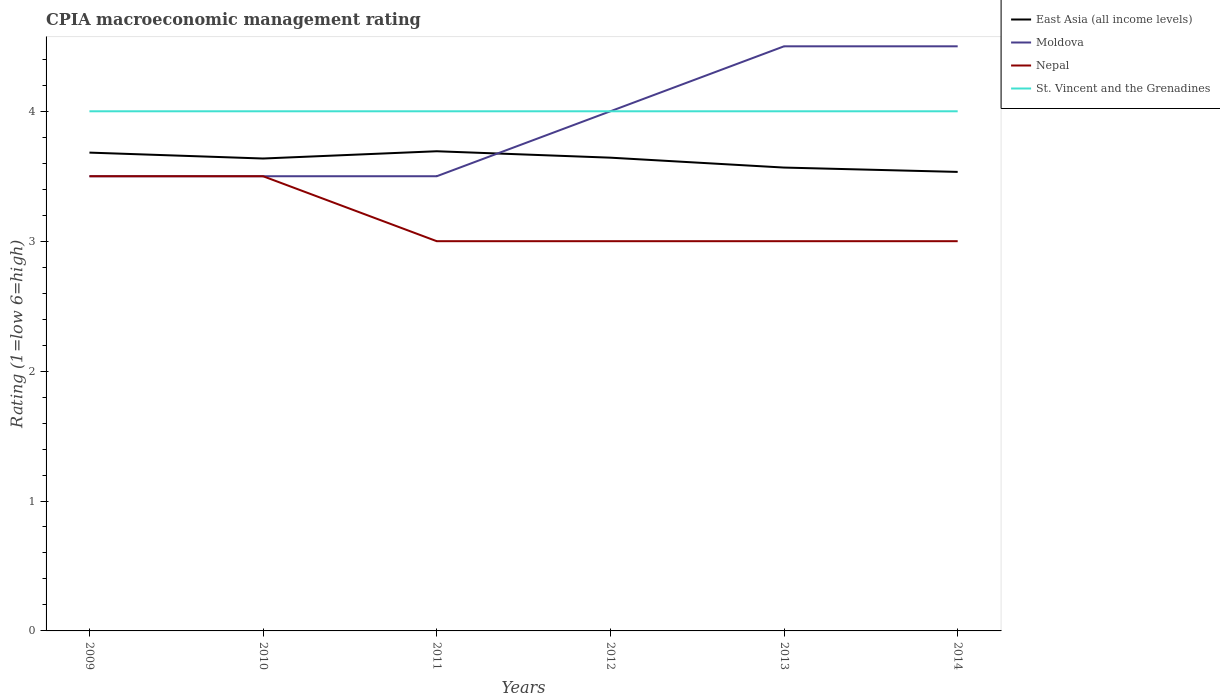Does the line corresponding to East Asia (all income levels) intersect with the line corresponding to Nepal?
Provide a succinct answer. No. In which year was the CPIA rating in Nepal maximum?
Provide a short and direct response. 2011. What is the total CPIA rating in St. Vincent and the Grenadines in the graph?
Your answer should be compact. 0. What is the difference between the highest and the second highest CPIA rating in Nepal?
Keep it short and to the point. 0.5. What is the difference between the highest and the lowest CPIA rating in St. Vincent and the Grenadines?
Provide a succinct answer. 0. Is the CPIA rating in East Asia (all income levels) strictly greater than the CPIA rating in Moldova over the years?
Give a very brief answer. No. How many lines are there?
Offer a very short reply. 4. How many years are there in the graph?
Provide a short and direct response. 6. What is the difference between two consecutive major ticks on the Y-axis?
Ensure brevity in your answer.  1. Does the graph contain any zero values?
Give a very brief answer. No. Does the graph contain grids?
Offer a very short reply. No. How are the legend labels stacked?
Provide a succinct answer. Vertical. What is the title of the graph?
Offer a terse response. CPIA macroeconomic management rating. What is the label or title of the Y-axis?
Your answer should be very brief. Rating (1=low 6=high). What is the Rating (1=low 6=high) in East Asia (all income levels) in 2009?
Your answer should be compact. 3.68. What is the Rating (1=low 6=high) in Nepal in 2009?
Give a very brief answer. 3.5. What is the Rating (1=low 6=high) in East Asia (all income levels) in 2010?
Keep it short and to the point. 3.64. What is the Rating (1=low 6=high) in Nepal in 2010?
Your response must be concise. 3.5. What is the Rating (1=low 6=high) in St. Vincent and the Grenadines in 2010?
Your response must be concise. 4. What is the Rating (1=low 6=high) in East Asia (all income levels) in 2011?
Make the answer very short. 3.69. What is the Rating (1=low 6=high) in St. Vincent and the Grenadines in 2011?
Offer a terse response. 4. What is the Rating (1=low 6=high) in East Asia (all income levels) in 2012?
Your response must be concise. 3.64. What is the Rating (1=low 6=high) of Moldova in 2012?
Make the answer very short. 4. What is the Rating (1=low 6=high) of East Asia (all income levels) in 2013?
Your response must be concise. 3.57. What is the Rating (1=low 6=high) in Nepal in 2013?
Provide a short and direct response. 3. What is the Rating (1=low 6=high) of St. Vincent and the Grenadines in 2013?
Ensure brevity in your answer.  4. What is the Rating (1=low 6=high) in East Asia (all income levels) in 2014?
Offer a very short reply. 3.53. What is the Rating (1=low 6=high) of Moldova in 2014?
Give a very brief answer. 4.5. What is the Rating (1=low 6=high) of Nepal in 2014?
Make the answer very short. 3. Across all years, what is the maximum Rating (1=low 6=high) of East Asia (all income levels)?
Provide a short and direct response. 3.69. Across all years, what is the maximum Rating (1=low 6=high) in Nepal?
Make the answer very short. 3.5. Across all years, what is the minimum Rating (1=low 6=high) of East Asia (all income levels)?
Your response must be concise. 3.53. Across all years, what is the minimum Rating (1=low 6=high) in St. Vincent and the Grenadines?
Offer a very short reply. 4. What is the total Rating (1=low 6=high) of East Asia (all income levels) in the graph?
Make the answer very short. 21.75. What is the total Rating (1=low 6=high) in Nepal in the graph?
Your response must be concise. 19. What is the total Rating (1=low 6=high) of St. Vincent and the Grenadines in the graph?
Provide a short and direct response. 24. What is the difference between the Rating (1=low 6=high) of East Asia (all income levels) in 2009 and that in 2010?
Ensure brevity in your answer.  0.05. What is the difference between the Rating (1=low 6=high) of Nepal in 2009 and that in 2010?
Your response must be concise. 0. What is the difference between the Rating (1=low 6=high) of St. Vincent and the Grenadines in 2009 and that in 2010?
Offer a very short reply. 0. What is the difference between the Rating (1=low 6=high) in East Asia (all income levels) in 2009 and that in 2011?
Your response must be concise. -0.01. What is the difference between the Rating (1=low 6=high) of East Asia (all income levels) in 2009 and that in 2012?
Your answer should be compact. 0.04. What is the difference between the Rating (1=low 6=high) of Moldova in 2009 and that in 2012?
Provide a short and direct response. -0.5. What is the difference between the Rating (1=low 6=high) in Nepal in 2009 and that in 2012?
Ensure brevity in your answer.  0.5. What is the difference between the Rating (1=low 6=high) in St. Vincent and the Grenadines in 2009 and that in 2012?
Ensure brevity in your answer.  0. What is the difference between the Rating (1=low 6=high) in East Asia (all income levels) in 2009 and that in 2013?
Your answer should be compact. 0.12. What is the difference between the Rating (1=low 6=high) of East Asia (all income levels) in 2009 and that in 2014?
Offer a very short reply. 0.15. What is the difference between the Rating (1=low 6=high) of Nepal in 2009 and that in 2014?
Your answer should be very brief. 0.5. What is the difference between the Rating (1=low 6=high) in East Asia (all income levels) in 2010 and that in 2011?
Your answer should be very brief. -0.06. What is the difference between the Rating (1=low 6=high) in Nepal in 2010 and that in 2011?
Your answer should be compact. 0.5. What is the difference between the Rating (1=low 6=high) in St. Vincent and the Grenadines in 2010 and that in 2011?
Give a very brief answer. 0. What is the difference between the Rating (1=low 6=high) in East Asia (all income levels) in 2010 and that in 2012?
Your answer should be compact. -0.01. What is the difference between the Rating (1=low 6=high) in Nepal in 2010 and that in 2012?
Your response must be concise. 0.5. What is the difference between the Rating (1=low 6=high) in East Asia (all income levels) in 2010 and that in 2013?
Ensure brevity in your answer.  0.07. What is the difference between the Rating (1=low 6=high) in Nepal in 2010 and that in 2013?
Provide a short and direct response. 0.5. What is the difference between the Rating (1=low 6=high) of East Asia (all income levels) in 2010 and that in 2014?
Your answer should be very brief. 0.1. What is the difference between the Rating (1=low 6=high) of Moldova in 2010 and that in 2014?
Keep it short and to the point. -1. What is the difference between the Rating (1=low 6=high) in St. Vincent and the Grenadines in 2010 and that in 2014?
Provide a succinct answer. 0. What is the difference between the Rating (1=low 6=high) in East Asia (all income levels) in 2011 and that in 2012?
Provide a short and direct response. 0.05. What is the difference between the Rating (1=low 6=high) in Moldova in 2011 and that in 2012?
Your answer should be compact. -0.5. What is the difference between the Rating (1=low 6=high) in Nepal in 2011 and that in 2012?
Provide a succinct answer. 0. What is the difference between the Rating (1=low 6=high) of St. Vincent and the Grenadines in 2011 and that in 2012?
Provide a succinct answer. 0. What is the difference between the Rating (1=low 6=high) in East Asia (all income levels) in 2011 and that in 2013?
Your answer should be compact. 0.13. What is the difference between the Rating (1=low 6=high) of Moldova in 2011 and that in 2013?
Your answer should be compact. -1. What is the difference between the Rating (1=low 6=high) in Nepal in 2011 and that in 2013?
Provide a short and direct response. 0. What is the difference between the Rating (1=low 6=high) in St. Vincent and the Grenadines in 2011 and that in 2013?
Your response must be concise. 0. What is the difference between the Rating (1=low 6=high) of East Asia (all income levels) in 2011 and that in 2014?
Provide a short and direct response. 0.16. What is the difference between the Rating (1=low 6=high) of Moldova in 2011 and that in 2014?
Your response must be concise. -1. What is the difference between the Rating (1=low 6=high) of St. Vincent and the Grenadines in 2011 and that in 2014?
Your answer should be very brief. 0. What is the difference between the Rating (1=low 6=high) of East Asia (all income levels) in 2012 and that in 2013?
Offer a terse response. 0.08. What is the difference between the Rating (1=low 6=high) in Moldova in 2012 and that in 2013?
Ensure brevity in your answer.  -0.5. What is the difference between the Rating (1=low 6=high) of East Asia (all income levels) in 2012 and that in 2014?
Your response must be concise. 0.11. What is the difference between the Rating (1=low 6=high) in Nepal in 2012 and that in 2014?
Give a very brief answer. 0. What is the difference between the Rating (1=low 6=high) of St. Vincent and the Grenadines in 2012 and that in 2014?
Keep it short and to the point. 0. What is the difference between the Rating (1=low 6=high) in Moldova in 2013 and that in 2014?
Keep it short and to the point. 0. What is the difference between the Rating (1=low 6=high) of East Asia (all income levels) in 2009 and the Rating (1=low 6=high) of Moldova in 2010?
Offer a very short reply. 0.18. What is the difference between the Rating (1=low 6=high) in East Asia (all income levels) in 2009 and the Rating (1=low 6=high) in Nepal in 2010?
Give a very brief answer. 0.18. What is the difference between the Rating (1=low 6=high) in East Asia (all income levels) in 2009 and the Rating (1=low 6=high) in St. Vincent and the Grenadines in 2010?
Offer a terse response. -0.32. What is the difference between the Rating (1=low 6=high) of Nepal in 2009 and the Rating (1=low 6=high) of St. Vincent and the Grenadines in 2010?
Keep it short and to the point. -0.5. What is the difference between the Rating (1=low 6=high) of East Asia (all income levels) in 2009 and the Rating (1=low 6=high) of Moldova in 2011?
Your response must be concise. 0.18. What is the difference between the Rating (1=low 6=high) in East Asia (all income levels) in 2009 and the Rating (1=low 6=high) in Nepal in 2011?
Your answer should be compact. 0.68. What is the difference between the Rating (1=low 6=high) in East Asia (all income levels) in 2009 and the Rating (1=low 6=high) in St. Vincent and the Grenadines in 2011?
Your response must be concise. -0.32. What is the difference between the Rating (1=low 6=high) of Moldova in 2009 and the Rating (1=low 6=high) of Nepal in 2011?
Your response must be concise. 0.5. What is the difference between the Rating (1=low 6=high) of East Asia (all income levels) in 2009 and the Rating (1=low 6=high) of Moldova in 2012?
Keep it short and to the point. -0.32. What is the difference between the Rating (1=low 6=high) of East Asia (all income levels) in 2009 and the Rating (1=low 6=high) of Nepal in 2012?
Make the answer very short. 0.68. What is the difference between the Rating (1=low 6=high) of East Asia (all income levels) in 2009 and the Rating (1=low 6=high) of St. Vincent and the Grenadines in 2012?
Your response must be concise. -0.32. What is the difference between the Rating (1=low 6=high) in East Asia (all income levels) in 2009 and the Rating (1=low 6=high) in Moldova in 2013?
Provide a succinct answer. -0.82. What is the difference between the Rating (1=low 6=high) of East Asia (all income levels) in 2009 and the Rating (1=low 6=high) of Nepal in 2013?
Offer a very short reply. 0.68. What is the difference between the Rating (1=low 6=high) of East Asia (all income levels) in 2009 and the Rating (1=low 6=high) of St. Vincent and the Grenadines in 2013?
Provide a succinct answer. -0.32. What is the difference between the Rating (1=low 6=high) in Moldova in 2009 and the Rating (1=low 6=high) in Nepal in 2013?
Offer a very short reply. 0.5. What is the difference between the Rating (1=low 6=high) in Moldova in 2009 and the Rating (1=low 6=high) in St. Vincent and the Grenadines in 2013?
Ensure brevity in your answer.  -0.5. What is the difference between the Rating (1=low 6=high) of East Asia (all income levels) in 2009 and the Rating (1=low 6=high) of Moldova in 2014?
Make the answer very short. -0.82. What is the difference between the Rating (1=low 6=high) in East Asia (all income levels) in 2009 and the Rating (1=low 6=high) in Nepal in 2014?
Keep it short and to the point. 0.68. What is the difference between the Rating (1=low 6=high) in East Asia (all income levels) in 2009 and the Rating (1=low 6=high) in St. Vincent and the Grenadines in 2014?
Offer a terse response. -0.32. What is the difference between the Rating (1=low 6=high) in Moldova in 2009 and the Rating (1=low 6=high) in Nepal in 2014?
Ensure brevity in your answer.  0.5. What is the difference between the Rating (1=low 6=high) in East Asia (all income levels) in 2010 and the Rating (1=low 6=high) in Moldova in 2011?
Give a very brief answer. 0.14. What is the difference between the Rating (1=low 6=high) in East Asia (all income levels) in 2010 and the Rating (1=low 6=high) in Nepal in 2011?
Make the answer very short. 0.64. What is the difference between the Rating (1=low 6=high) in East Asia (all income levels) in 2010 and the Rating (1=low 6=high) in St. Vincent and the Grenadines in 2011?
Your answer should be compact. -0.36. What is the difference between the Rating (1=low 6=high) of East Asia (all income levels) in 2010 and the Rating (1=low 6=high) of Moldova in 2012?
Your answer should be very brief. -0.36. What is the difference between the Rating (1=low 6=high) in East Asia (all income levels) in 2010 and the Rating (1=low 6=high) in Nepal in 2012?
Ensure brevity in your answer.  0.64. What is the difference between the Rating (1=low 6=high) of East Asia (all income levels) in 2010 and the Rating (1=low 6=high) of St. Vincent and the Grenadines in 2012?
Make the answer very short. -0.36. What is the difference between the Rating (1=low 6=high) of Moldova in 2010 and the Rating (1=low 6=high) of Nepal in 2012?
Give a very brief answer. 0.5. What is the difference between the Rating (1=low 6=high) in East Asia (all income levels) in 2010 and the Rating (1=low 6=high) in Moldova in 2013?
Ensure brevity in your answer.  -0.86. What is the difference between the Rating (1=low 6=high) in East Asia (all income levels) in 2010 and the Rating (1=low 6=high) in Nepal in 2013?
Make the answer very short. 0.64. What is the difference between the Rating (1=low 6=high) in East Asia (all income levels) in 2010 and the Rating (1=low 6=high) in St. Vincent and the Grenadines in 2013?
Provide a short and direct response. -0.36. What is the difference between the Rating (1=low 6=high) of Moldova in 2010 and the Rating (1=low 6=high) of St. Vincent and the Grenadines in 2013?
Offer a terse response. -0.5. What is the difference between the Rating (1=low 6=high) in Nepal in 2010 and the Rating (1=low 6=high) in St. Vincent and the Grenadines in 2013?
Offer a very short reply. -0.5. What is the difference between the Rating (1=low 6=high) of East Asia (all income levels) in 2010 and the Rating (1=low 6=high) of Moldova in 2014?
Offer a terse response. -0.86. What is the difference between the Rating (1=low 6=high) of East Asia (all income levels) in 2010 and the Rating (1=low 6=high) of Nepal in 2014?
Give a very brief answer. 0.64. What is the difference between the Rating (1=low 6=high) in East Asia (all income levels) in 2010 and the Rating (1=low 6=high) in St. Vincent and the Grenadines in 2014?
Your answer should be compact. -0.36. What is the difference between the Rating (1=low 6=high) of Nepal in 2010 and the Rating (1=low 6=high) of St. Vincent and the Grenadines in 2014?
Give a very brief answer. -0.5. What is the difference between the Rating (1=low 6=high) of East Asia (all income levels) in 2011 and the Rating (1=low 6=high) of Moldova in 2012?
Keep it short and to the point. -0.31. What is the difference between the Rating (1=low 6=high) of East Asia (all income levels) in 2011 and the Rating (1=low 6=high) of Nepal in 2012?
Ensure brevity in your answer.  0.69. What is the difference between the Rating (1=low 6=high) of East Asia (all income levels) in 2011 and the Rating (1=low 6=high) of St. Vincent and the Grenadines in 2012?
Offer a very short reply. -0.31. What is the difference between the Rating (1=low 6=high) in East Asia (all income levels) in 2011 and the Rating (1=low 6=high) in Moldova in 2013?
Provide a short and direct response. -0.81. What is the difference between the Rating (1=low 6=high) in East Asia (all income levels) in 2011 and the Rating (1=low 6=high) in Nepal in 2013?
Give a very brief answer. 0.69. What is the difference between the Rating (1=low 6=high) in East Asia (all income levels) in 2011 and the Rating (1=low 6=high) in St. Vincent and the Grenadines in 2013?
Ensure brevity in your answer.  -0.31. What is the difference between the Rating (1=low 6=high) in Moldova in 2011 and the Rating (1=low 6=high) in Nepal in 2013?
Make the answer very short. 0.5. What is the difference between the Rating (1=low 6=high) of East Asia (all income levels) in 2011 and the Rating (1=low 6=high) of Moldova in 2014?
Your answer should be compact. -0.81. What is the difference between the Rating (1=low 6=high) of East Asia (all income levels) in 2011 and the Rating (1=low 6=high) of Nepal in 2014?
Make the answer very short. 0.69. What is the difference between the Rating (1=low 6=high) of East Asia (all income levels) in 2011 and the Rating (1=low 6=high) of St. Vincent and the Grenadines in 2014?
Keep it short and to the point. -0.31. What is the difference between the Rating (1=low 6=high) of Moldova in 2011 and the Rating (1=low 6=high) of St. Vincent and the Grenadines in 2014?
Give a very brief answer. -0.5. What is the difference between the Rating (1=low 6=high) in Nepal in 2011 and the Rating (1=low 6=high) in St. Vincent and the Grenadines in 2014?
Offer a very short reply. -1. What is the difference between the Rating (1=low 6=high) of East Asia (all income levels) in 2012 and the Rating (1=low 6=high) of Moldova in 2013?
Your answer should be very brief. -0.86. What is the difference between the Rating (1=low 6=high) in East Asia (all income levels) in 2012 and the Rating (1=low 6=high) in Nepal in 2013?
Offer a terse response. 0.64. What is the difference between the Rating (1=low 6=high) of East Asia (all income levels) in 2012 and the Rating (1=low 6=high) of St. Vincent and the Grenadines in 2013?
Your response must be concise. -0.36. What is the difference between the Rating (1=low 6=high) in Moldova in 2012 and the Rating (1=low 6=high) in Nepal in 2013?
Your answer should be compact. 1. What is the difference between the Rating (1=low 6=high) of Moldova in 2012 and the Rating (1=low 6=high) of St. Vincent and the Grenadines in 2013?
Your answer should be compact. 0. What is the difference between the Rating (1=low 6=high) in East Asia (all income levels) in 2012 and the Rating (1=low 6=high) in Moldova in 2014?
Give a very brief answer. -0.86. What is the difference between the Rating (1=low 6=high) of East Asia (all income levels) in 2012 and the Rating (1=low 6=high) of Nepal in 2014?
Provide a succinct answer. 0.64. What is the difference between the Rating (1=low 6=high) in East Asia (all income levels) in 2012 and the Rating (1=low 6=high) in St. Vincent and the Grenadines in 2014?
Make the answer very short. -0.36. What is the difference between the Rating (1=low 6=high) in Moldova in 2012 and the Rating (1=low 6=high) in Nepal in 2014?
Keep it short and to the point. 1. What is the difference between the Rating (1=low 6=high) in Moldova in 2012 and the Rating (1=low 6=high) in St. Vincent and the Grenadines in 2014?
Your answer should be very brief. 0. What is the difference between the Rating (1=low 6=high) in East Asia (all income levels) in 2013 and the Rating (1=low 6=high) in Moldova in 2014?
Provide a succinct answer. -0.93. What is the difference between the Rating (1=low 6=high) in East Asia (all income levels) in 2013 and the Rating (1=low 6=high) in Nepal in 2014?
Offer a terse response. 0.57. What is the difference between the Rating (1=low 6=high) of East Asia (all income levels) in 2013 and the Rating (1=low 6=high) of St. Vincent and the Grenadines in 2014?
Offer a terse response. -0.43. What is the difference between the Rating (1=low 6=high) of Nepal in 2013 and the Rating (1=low 6=high) of St. Vincent and the Grenadines in 2014?
Provide a short and direct response. -1. What is the average Rating (1=low 6=high) of East Asia (all income levels) per year?
Provide a succinct answer. 3.63. What is the average Rating (1=low 6=high) in Moldova per year?
Make the answer very short. 3.92. What is the average Rating (1=low 6=high) in Nepal per year?
Keep it short and to the point. 3.17. What is the average Rating (1=low 6=high) of St. Vincent and the Grenadines per year?
Provide a short and direct response. 4. In the year 2009, what is the difference between the Rating (1=low 6=high) of East Asia (all income levels) and Rating (1=low 6=high) of Moldova?
Your answer should be compact. 0.18. In the year 2009, what is the difference between the Rating (1=low 6=high) in East Asia (all income levels) and Rating (1=low 6=high) in Nepal?
Offer a very short reply. 0.18. In the year 2009, what is the difference between the Rating (1=low 6=high) in East Asia (all income levels) and Rating (1=low 6=high) in St. Vincent and the Grenadines?
Provide a short and direct response. -0.32. In the year 2009, what is the difference between the Rating (1=low 6=high) of Moldova and Rating (1=low 6=high) of St. Vincent and the Grenadines?
Your answer should be very brief. -0.5. In the year 2009, what is the difference between the Rating (1=low 6=high) of Nepal and Rating (1=low 6=high) of St. Vincent and the Grenadines?
Your response must be concise. -0.5. In the year 2010, what is the difference between the Rating (1=low 6=high) in East Asia (all income levels) and Rating (1=low 6=high) in Moldova?
Ensure brevity in your answer.  0.14. In the year 2010, what is the difference between the Rating (1=low 6=high) in East Asia (all income levels) and Rating (1=low 6=high) in Nepal?
Your response must be concise. 0.14. In the year 2010, what is the difference between the Rating (1=low 6=high) of East Asia (all income levels) and Rating (1=low 6=high) of St. Vincent and the Grenadines?
Offer a terse response. -0.36. In the year 2010, what is the difference between the Rating (1=low 6=high) in Moldova and Rating (1=low 6=high) in St. Vincent and the Grenadines?
Offer a very short reply. -0.5. In the year 2010, what is the difference between the Rating (1=low 6=high) of Nepal and Rating (1=low 6=high) of St. Vincent and the Grenadines?
Offer a terse response. -0.5. In the year 2011, what is the difference between the Rating (1=low 6=high) in East Asia (all income levels) and Rating (1=low 6=high) in Moldova?
Ensure brevity in your answer.  0.19. In the year 2011, what is the difference between the Rating (1=low 6=high) in East Asia (all income levels) and Rating (1=low 6=high) in Nepal?
Your answer should be compact. 0.69. In the year 2011, what is the difference between the Rating (1=low 6=high) of East Asia (all income levels) and Rating (1=low 6=high) of St. Vincent and the Grenadines?
Ensure brevity in your answer.  -0.31. In the year 2011, what is the difference between the Rating (1=low 6=high) of Moldova and Rating (1=low 6=high) of Nepal?
Your answer should be compact. 0.5. In the year 2012, what is the difference between the Rating (1=low 6=high) of East Asia (all income levels) and Rating (1=low 6=high) of Moldova?
Make the answer very short. -0.36. In the year 2012, what is the difference between the Rating (1=low 6=high) in East Asia (all income levels) and Rating (1=low 6=high) in Nepal?
Your response must be concise. 0.64. In the year 2012, what is the difference between the Rating (1=low 6=high) of East Asia (all income levels) and Rating (1=low 6=high) of St. Vincent and the Grenadines?
Provide a succinct answer. -0.36. In the year 2012, what is the difference between the Rating (1=low 6=high) in Moldova and Rating (1=low 6=high) in Nepal?
Ensure brevity in your answer.  1. In the year 2012, what is the difference between the Rating (1=low 6=high) of Moldova and Rating (1=low 6=high) of St. Vincent and the Grenadines?
Ensure brevity in your answer.  0. In the year 2012, what is the difference between the Rating (1=low 6=high) in Nepal and Rating (1=low 6=high) in St. Vincent and the Grenadines?
Make the answer very short. -1. In the year 2013, what is the difference between the Rating (1=low 6=high) of East Asia (all income levels) and Rating (1=low 6=high) of Moldova?
Give a very brief answer. -0.93. In the year 2013, what is the difference between the Rating (1=low 6=high) in East Asia (all income levels) and Rating (1=low 6=high) in Nepal?
Offer a very short reply. 0.57. In the year 2013, what is the difference between the Rating (1=low 6=high) of East Asia (all income levels) and Rating (1=low 6=high) of St. Vincent and the Grenadines?
Provide a succinct answer. -0.43. In the year 2013, what is the difference between the Rating (1=low 6=high) in Moldova and Rating (1=low 6=high) in Nepal?
Ensure brevity in your answer.  1.5. In the year 2013, what is the difference between the Rating (1=low 6=high) of Moldova and Rating (1=low 6=high) of St. Vincent and the Grenadines?
Make the answer very short. 0.5. In the year 2014, what is the difference between the Rating (1=low 6=high) of East Asia (all income levels) and Rating (1=low 6=high) of Moldova?
Your response must be concise. -0.97. In the year 2014, what is the difference between the Rating (1=low 6=high) of East Asia (all income levels) and Rating (1=low 6=high) of Nepal?
Ensure brevity in your answer.  0.53. In the year 2014, what is the difference between the Rating (1=low 6=high) in East Asia (all income levels) and Rating (1=low 6=high) in St. Vincent and the Grenadines?
Offer a very short reply. -0.47. In the year 2014, what is the difference between the Rating (1=low 6=high) of Moldova and Rating (1=low 6=high) of Nepal?
Your response must be concise. 1.5. What is the ratio of the Rating (1=low 6=high) of East Asia (all income levels) in 2009 to that in 2010?
Offer a terse response. 1.01. What is the ratio of the Rating (1=low 6=high) of Moldova in 2009 to that in 2010?
Your answer should be very brief. 1. What is the ratio of the Rating (1=low 6=high) of Moldova in 2009 to that in 2011?
Keep it short and to the point. 1. What is the ratio of the Rating (1=low 6=high) in Nepal in 2009 to that in 2011?
Offer a terse response. 1.17. What is the ratio of the Rating (1=low 6=high) in East Asia (all income levels) in 2009 to that in 2012?
Make the answer very short. 1.01. What is the ratio of the Rating (1=low 6=high) of Moldova in 2009 to that in 2012?
Your response must be concise. 0.88. What is the ratio of the Rating (1=low 6=high) in Nepal in 2009 to that in 2012?
Ensure brevity in your answer.  1.17. What is the ratio of the Rating (1=low 6=high) of East Asia (all income levels) in 2009 to that in 2013?
Provide a short and direct response. 1.03. What is the ratio of the Rating (1=low 6=high) in Nepal in 2009 to that in 2013?
Give a very brief answer. 1.17. What is the ratio of the Rating (1=low 6=high) of East Asia (all income levels) in 2009 to that in 2014?
Give a very brief answer. 1.04. What is the ratio of the Rating (1=low 6=high) in Nepal in 2009 to that in 2014?
Your answer should be compact. 1.17. What is the ratio of the Rating (1=low 6=high) in St. Vincent and the Grenadines in 2009 to that in 2014?
Keep it short and to the point. 1. What is the ratio of the Rating (1=low 6=high) of Moldova in 2010 to that in 2011?
Offer a terse response. 1. What is the ratio of the Rating (1=low 6=high) of Nepal in 2010 to that in 2011?
Keep it short and to the point. 1.17. What is the ratio of the Rating (1=low 6=high) in East Asia (all income levels) in 2010 to that in 2012?
Provide a short and direct response. 1. What is the ratio of the Rating (1=low 6=high) in Nepal in 2010 to that in 2012?
Your answer should be very brief. 1.17. What is the ratio of the Rating (1=low 6=high) of East Asia (all income levels) in 2010 to that in 2013?
Make the answer very short. 1.02. What is the ratio of the Rating (1=low 6=high) in Moldova in 2010 to that in 2013?
Keep it short and to the point. 0.78. What is the ratio of the Rating (1=low 6=high) of Nepal in 2010 to that in 2013?
Provide a short and direct response. 1.17. What is the ratio of the Rating (1=low 6=high) in East Asia (all income levels) in 2010 to that in 2014?
Ensure brevity in your answer.  1.03. What is the ratio of the Rating (1=low 6=high) of East Asia (all income levels) in 2011 to that in 2012?
Offer a terse response. 1.01. What is the ratio of the Rating (1=low 6=high) in Moldova in 2011 to that in 2012?
Provide a succinct answer. 0.88. What is the ratio of the Rating (1=low 6=high) of East Asia (all income levels) in 2011 to that in 2013?
Your answer should be compact. 1.04. What is the ratio of the Rating (1=low 6=high) in Nepal in 2011 to that in 2013?
Offer a very short reply. 1. What is the ratio of the Rating (1=low 6=high) in St. Vincent and the Grenadines in 2011 to that in 2013?
Offer a very short reply. 1. What is the ratio of the Rating (1=low 6=high) in East Asia (all income levels) in 2011 to that in 2014?
Your answer should be compact. 1.04. What is the ratio of the Rating (1=low 6=high) of Nepal in 2011 to that in 2014?
Keep it short and to the point. 1. What is the ratio of the Rating (1=low 6=high) of East Asia (all income levels) in 2012 to that in 2013?
Provide a succinct answer. 1.02. What is the ratio of the Rating (1=low 6=high) in Moldova in 2012 to that in 2013?
Make the answer very short. 0.89. What is the ratio of the Rating (1=low 6=high) of St. Vincent and the Grenadines in 2012 to that in 2013?
Give a very brief answer. 1. What is the ratio of the Rating (1=low 6=high) in East Asia (all income levels) in 2012 to that in 2014?
Ensure brevity in your answer.  1.03. What is the ratio of the Rating (1=low 6=high) of East Asia (all income levels) in 2013 to that in 2014?
Ensure brevity in your answer.  1.01. What is the ratio of the Rating (1=low 6=high) of Nepal in 2013 to that in 2014?
Your answer should be compact. 1. What is the ratio of the Rating (1=low 6=high) of St. Vincent and the Grenadines in 2013 to that in 2014?
Give a very brief answer. 1. What is the difference between the highest and the second highest Rating (1=low 6=high) of East Asia (all income levels)?
Provide a succinct answer. 0.01. What is the difference between the highest and the second highest Rating (1=low 6=high) in Moldova?
Offer a terse response. 0. What is the difference between the highest and the second highest Rating (1=low 6=high) in Nepal?
Provide a succinct answer. 0. What is the difference between the highest and the lowest Rating (1=low 6=high) in East Asia (all income levels)?
Your answer should be very brief. 0.16. What is the difference between the highest and the lowest Rating (1=low 6=high) in Nepal?
Your response must be concise. 0.5. What is the difference between the highest and the lowest Rating (1=low 6=high) in St. Vincent and the Grenadines?
Your answer should be very brief. 0. 